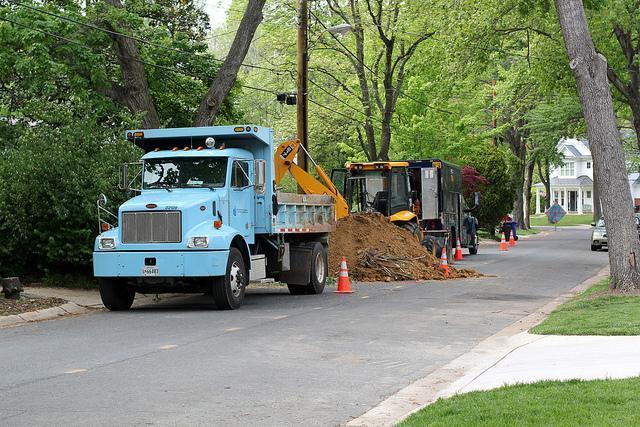How many cones?
Give a very brief answer. 5. How many orange cones are there?
Give a very brief answer. 5. How many trucks are there?
Give a very brief answer. 2. 